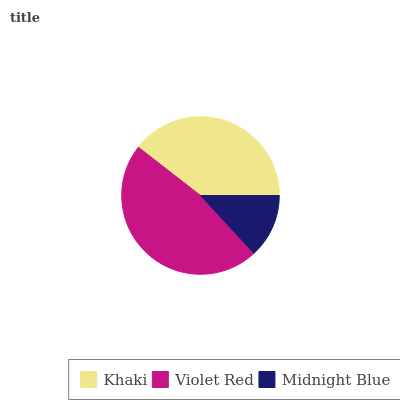Is Midnight Blue the minimum?
Answer yes or no. Yes. Is Violet Red the maximum?
Answer yes or no. Yes. Is Violet Red the minimum?
Answer yes or no. No. Is Midnight Blue the maximum?
Answer yes or no. No. Is Violet Red greater than Midnight Blue?
Answer yes or no. Yes. Is Midnight Blue less than Violet Red?
Answer yes or no. Yes. Is Midnight Blue greater than Violet Red?
Answer yes or no. No. Is Violet Red less than Midnight Blue?
Answer yes or no. No. Is Khaki the high median?
Answer yes or no. Yes. Is Khaki the low median?
Answer yes or no. Yes. Is Violet Red the high median?
Answer yes or no. No. Is Violet Red the low median?
Answer yes or no. No. 